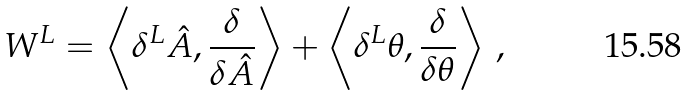<formula> <loc_0><loc_0><loc_500><loc_500>W ^ { L } = \left \langle \delta ^ { L } \hat { A } , \frac { \delta } { \delta \hat { A } } \right \rangle + \left \langle \delta ^ { L } \theta , \frac { \delta } { \delta \theta } \right \rangle \, ,</formula> 